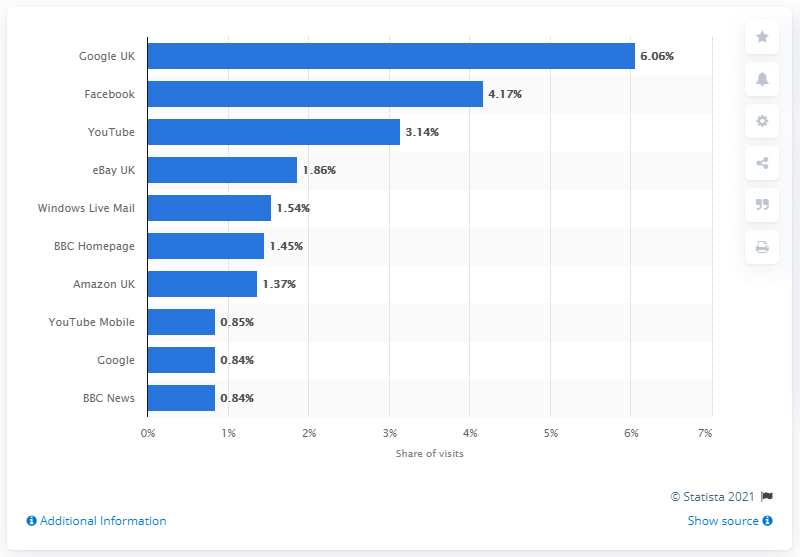Outline some significant characteristics in this image. According to the data, Facebook came in second with 4.17 percent of visits. 